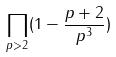Convert formula to latex. <formula><loc_0><loc_0><loc_500><loc_500>\prod _ { p > 2 } ( 1 - \frac { p + 2 } { p ^ { 3 } } )</formula> 